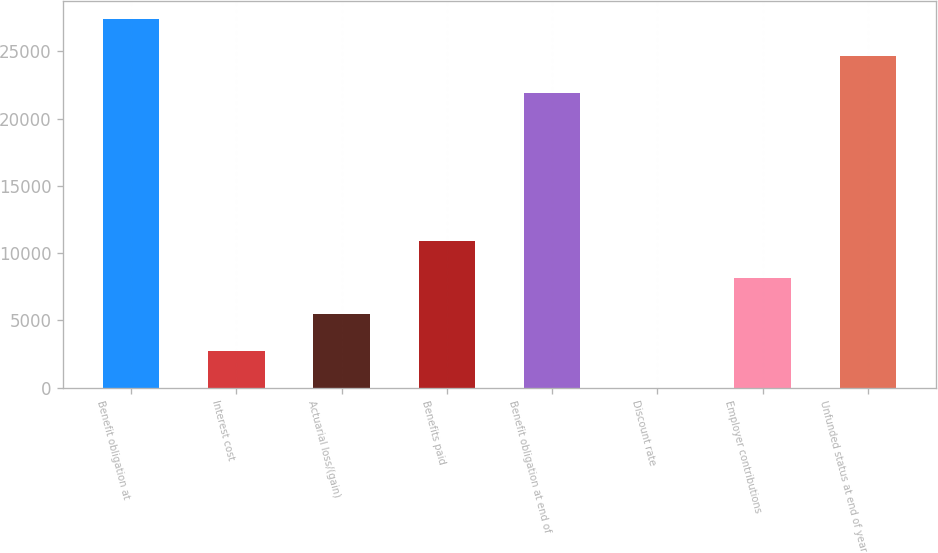Convert chart to OTSL. <chart><loc_0><loc_0><loc_500><loc_500><bar_chart><fcel>Benefit obligation at<fcel>Interest cost<fcel>Actuarial loss/(gain)<fcel>Benefits paid<fcel>Benefit obligation at end of<fcel>Discount rate<fcel>Employer contributions<fcel>Unfunded status at end of year<nl><fcel>27379.7<fcel>2725.85<fcel>5448.2<fcel>10892.9<fcel>21935<fcel>3.5<fcel>8170.55<fcel>24657.3<nl></chart> 